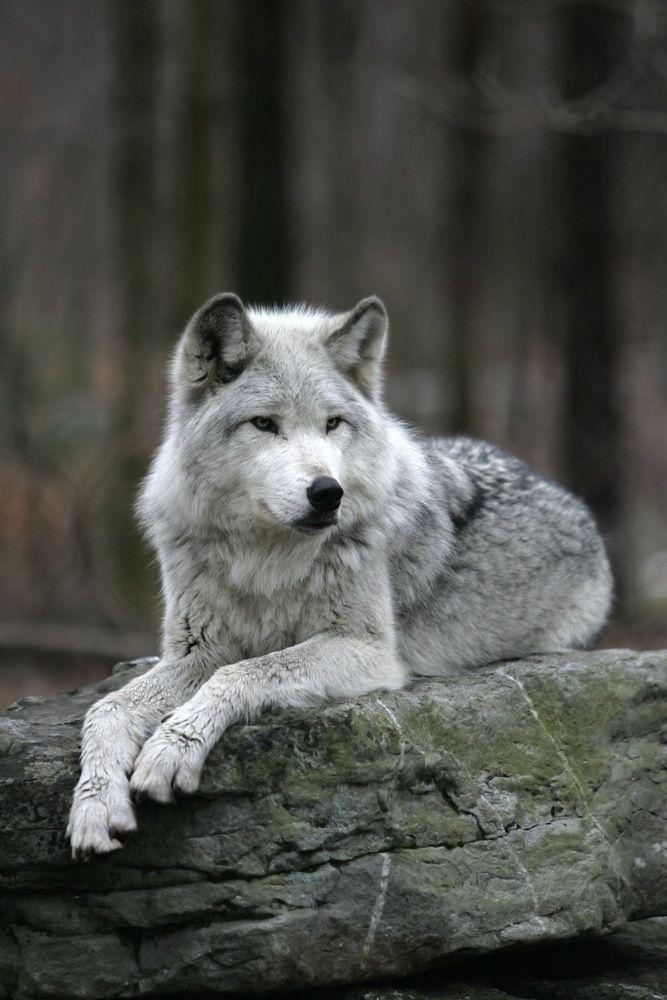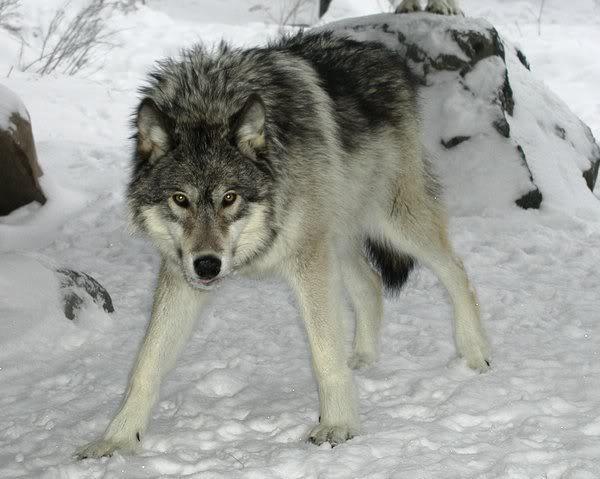The first image is the image on the left, the second image is the image on the right. Examine the images to the left and right. Is the description "There is a wolf lying down with its head raised." accurate? Answer yes or no. Yes. 